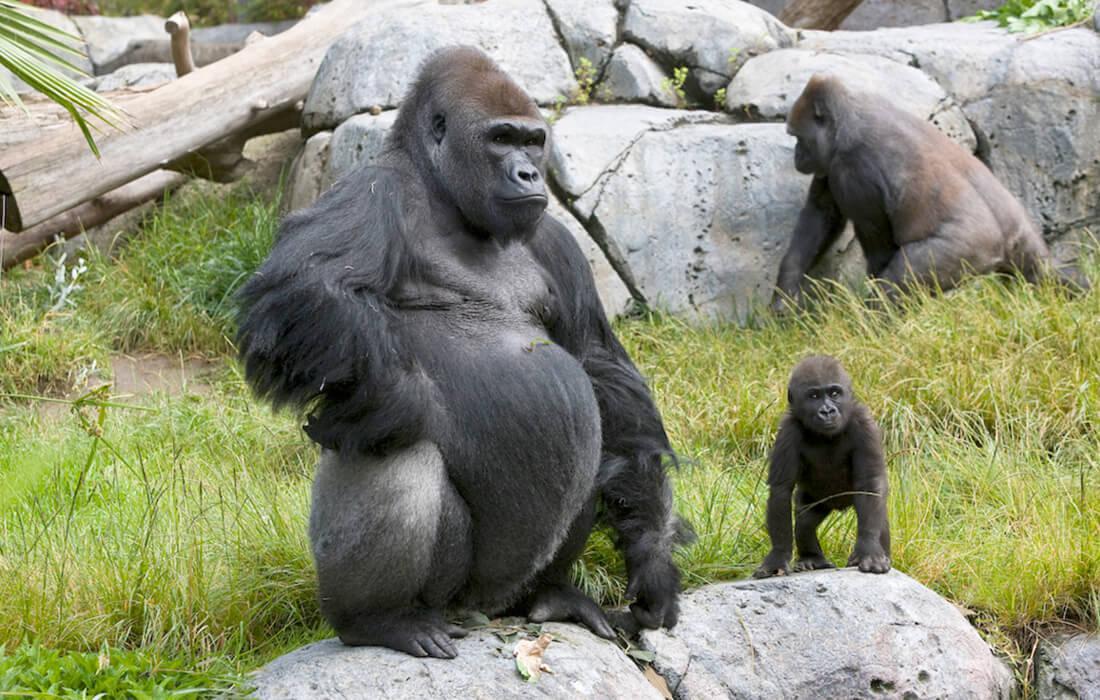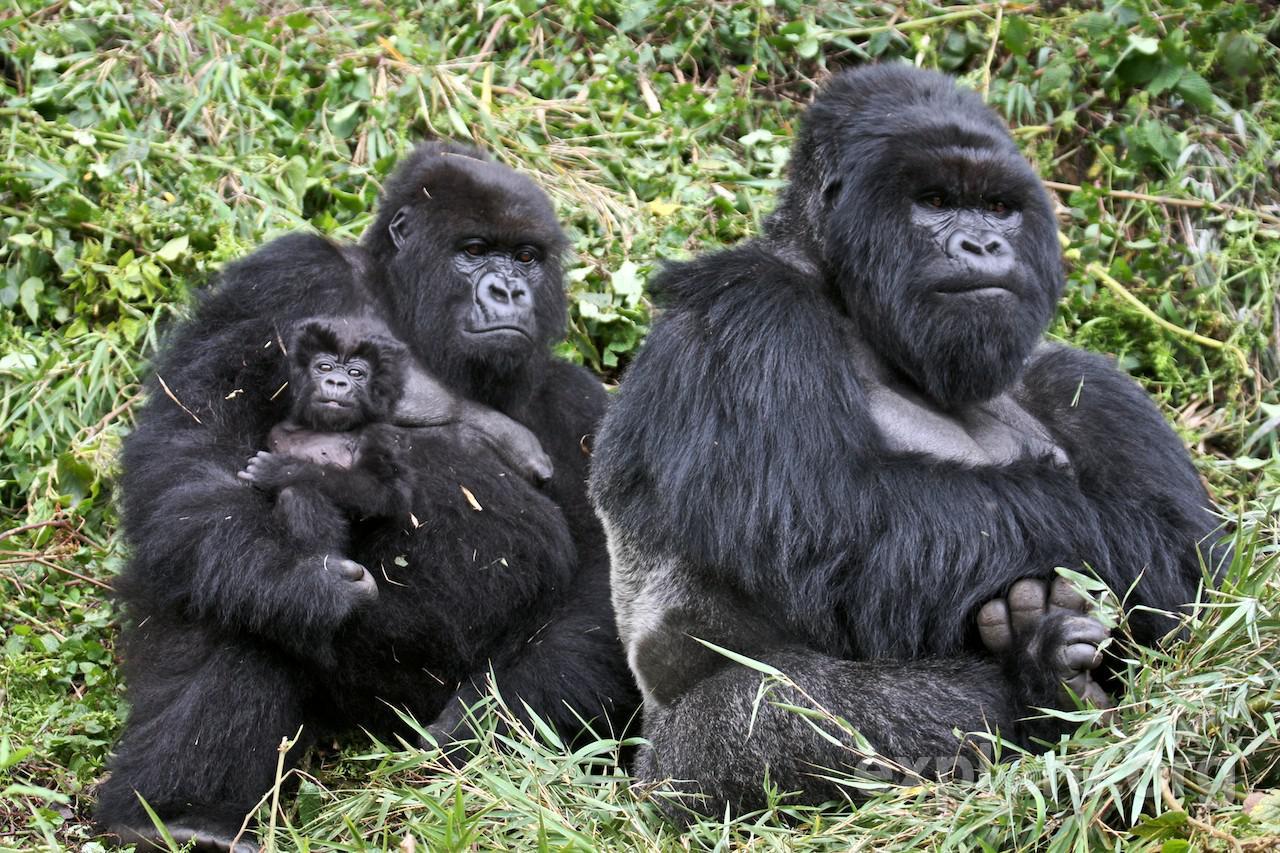The first image is the image on the left, the second image is the image on the right. Evaluate the accuracy of this statement regarding the images: "The image on the right shows exactly one adult gorilla.". Is it true? Answer yes or no. No. The first image is the image on the left, the second image is the image on the right. Considering the images on both sides, is "There are monkeys on rocks in one of the images" valid? Answer yes or no. Yes. 